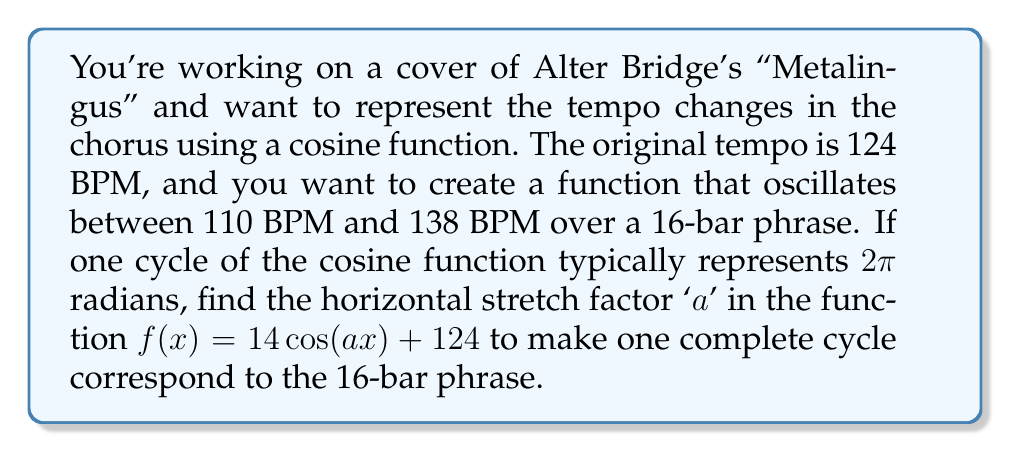Can you solve this math problem? To solve this problem, let's follow these steps:

1) In a standard cosine function, one complete cycle occurs over 2π radians. We need to stretch this to fit 16 bars.

2) Let's define our x-axis in terms of bars. We want:
   $f(0) = f(16)$, representing a complete cycle over 16 bars.

3) For a cosine function $\cos(ax)$, one complete cycle occurs when:
   $ax = 2\pi$

4) Substituting our desired cycle length:
   $a(16) = 2\pi$

5) Solving for a:
   $a = \frac{2\pi}{16} = \frac{\pi}{8}$

6) To verify, let's check the function:
   $f(x) = 14\cos(\frac{\pi}{8}x) + 124$

   At $x = 0$: $f(0) = 14\cos(0) + 124 = 138$ (maximum)
   At $x = 8$: $f(8) = 14\cos(\pi) + 124 = 110$ (minimum)
   At $x = 16$: $f(16) = 14\cos(2\pi) + 124 = 138$ (back to maximum)

This confirms that the function oscillates between 110 and 138 BPM over the 16-bar phrase as required.
Answer: The horizontal stretch factor $a$ is $\frac{\pi}{8}$. 